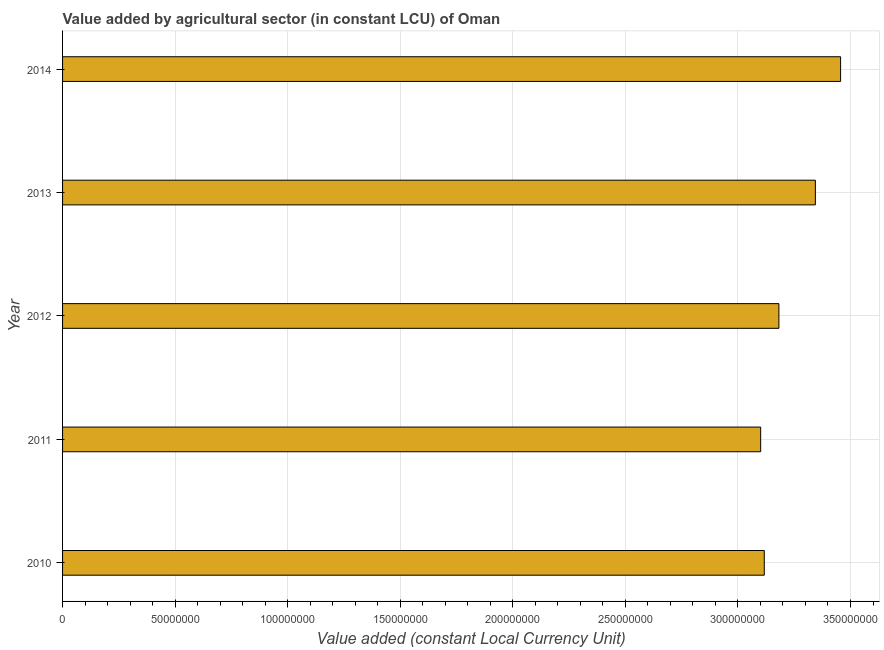Does the graph contain grids?
Provide a succinct answer. Yes. What is the title of the graph?
Offer a terse response. Value added by agricultural sector (in constant LCU) of Oman. What is the label or title of the X-axis?
Offer a terse response. Value added (constant Local Currency Unit). What is the value added by agriculture sector in 2010?
Give a very brief answer. 3.12e+08. Across all years, what is the maximum value added by agriculture sector?
Keep it short and to the point. 3.46e+08. Across all years, what is the minimum value added by agriculture sector?
Your response must be concise. 3.10e+08. In which year was the value added by agriculture sector minimum?
Provide a succinct answer. 2011. What is the sum of the value added by agriculture sector?
Keep it short and to the point. 1.62e+09. What is the difference between the value added by agriculture sector in 2010 and 2011?
Offer a very short reply. 1.60e+06. What is the average value added by agriculture sector per year?
Keep it short and to the point. 3.24e+08. What is the median value added by agriculture sector?
Your answer should be compact. 3.18e+08. What is the difference between the highest and the second highest value added by agriculture sector?
Keep it short and to the point. 1.12e+07. Is the sum of the value added by agriculture sector in 2011 and 2013 greater than the maximum value added by agriculture sector across all years?
Your response must be concise. Yes. What is the difference between the highest and the lowest value added by agriculture sector?
Offer a terse response. 3.55e+07. In how many years, is the value added by agriculture sector greater than the average value added by agriculture sector taken over all years?
Offer a terse response. 2. How many bars are there?
Give a very brief answer. 5. Are all the bars in the graph horizontal?
Ensure brevity in your answer.  Yes. What is the difference between two consecutive major ticks on the X-axis?
Offer a terse response. 5.00e+07. What is the Value added (constant Local Currency Unit) in 2010?
Make the answer very short. 3.12e+08. What is the Value added (constant Local Currency Unit) of 2011?
Make the answer very short. 3.10e+08. What is the Value added (constant Local Currency Unit) in 2012?
Give a very brief answer. 3.18e+08. What is the Value added (constant Local Currency Unit) in 2013?
Offer a very short reply. 3.34e+08. What is the Value added (constant Local Currency Unit) in 2014?
Provide a short and direct response. 3.46e+08. What is the difference between the Value added (constant Local Currency Unit) in 2010 and 2011?
Your answer should be compact. 1.60e+06. What is the difference between the Value added (constant Local Currency Unit) in 2010 and 2012?
Your answer should be compact. -6.50e+06. What is the difference between the Value added (constant Local Currency Unit) in 2010 and 2013?
Offer a very short reply. -2.27e+07. What is the difference between the Value added (constant Local Currency Unit) in 2010 and 2014?
Make the answer very short. -3.39e+07. What is the difference between the Value added (constant Local Currency Unit) in 2011 and 2012?
Offer a terse response. -8.10e+06. What is the difference between the Value added (constant Local Currency Unit) in 2011 and 2013?
Give a very brief answer. -2.43e+07. What is the difference between the Value added (constant Local Currency Unit) in 2011 and 2014?
Your response must be concise. -3.55e+07. What is the difference between the Value added (constant Local Currency Unit) in 2012 and 2013?
Your answer should be compact. -1.62e+07. What is the difference between the Value added (constant Local Currency Unit) in 2012 and 2014?
Your response must be concise. -2.74e+07. What is the difference between the Value added (constant Local Currency Unit) in 2013 and 2014?
Your response must be concise. -1.12e+07. What is the ratio of the Value added (constant Local Currency Unit) in 2010 to that in 2011?
Your answer should be compact. 1. What is the ratio of the Value added (constant Local Currency Unit) in 2010 to that in 2012?
Your answer should be compact. 0.98. What is the ratio of the Value added (constant Local Currency Unit) in 2010 to that in 2013?
Your response must be concise. 0.93. What is the ratio of the Value added (constant Local Currency Unit) in 2010 to that in 2014?
Provide a succinct answer. 0.9. What is the ratio of the Value added (constant Local Currency Unit) in 2011 to that in 2012?
Your answer should be compact. 0.97. What is the ratio of the Value added (constant Local Currency Unit) in 2011 to that in 2013?
Make the answer very short. 0.93. What is the ratio of the Value added (constant Local Currency Unit) in 2011 to that in 2014?
Ensure brevity in your answer.  0.9. What is the ratio of the Value added (constant Local Currency Unit) in 2012 to that in 2014?
Offer a very short reply. 0.92. What is the ratio of the Value added (constant Local Currency Unit) in 2013 to that in 2014?
Keep it short and to the point. 0.97. 